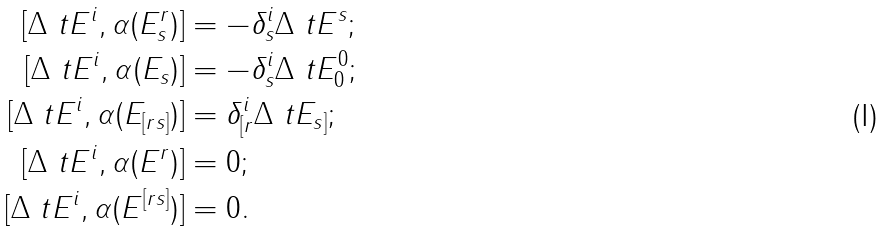<formula> <loc_0><loc_0><loc_500><loc_500>[ \Delta \ t E ^ { i } , \alpha ( E ^ { r } _ { s } ) ] & = - \delta ^ { i } _ { s } \Delta \ t E ^ { s } ; \\ [ \Delta \ t E ^ { i } , \alpha ( E _ { s } ) ] & = - \delta ^ { i } _ { s } \Delta \ t E ^ { 0 } _ { 0 } ; \\ [ \Delta \ t E ^ { i } , \alpha ( E _ { [ r s ] } ) ] & = \delta ^ { i } _ { [ r } \Delta \ t E _ { s ] } ; \\ [ \Delta \ t E ^ { i } , \alpha ( E ^ { r } ) ] & = 0 ; \\ [ \Delta \ t E ^ { i } , \alpha ( E ^ { [ r s ] } ) ] & = 0 .</formula> 